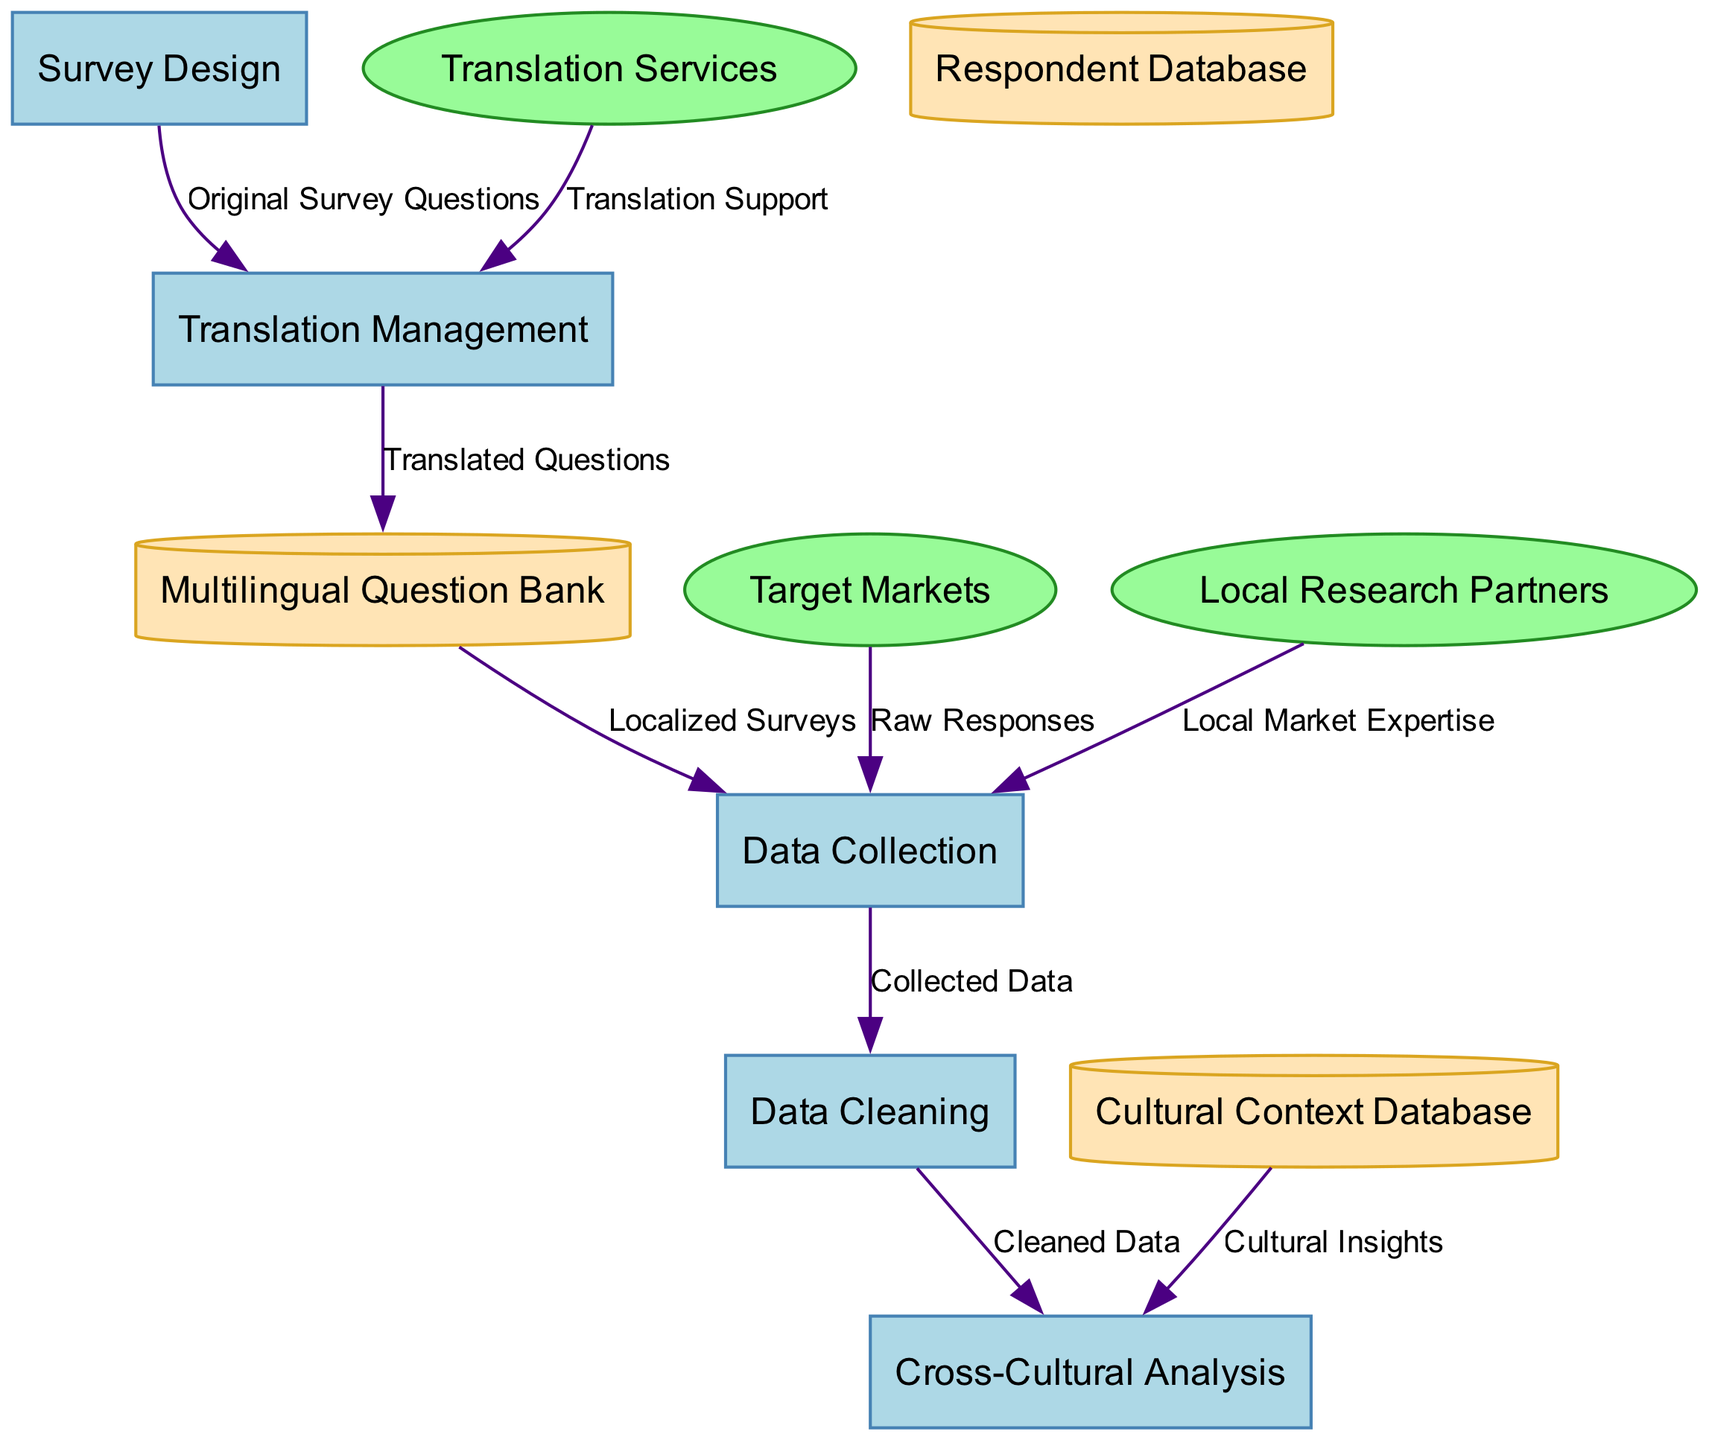What are the main processes in the diagram? The diagram lists five processes. These are: Survey Design, Translation Management, Data Collection, Data Cleaning, and Cross-Cultural Analysis.
Answer: Survey Design, Translation Management, Data Collection, Data Cleaning, Cross-Cultural Analysis Which node receives "Raw Responses"? "Data Collection" receives "Raw Responses" from "Target Markets." This is directly indicated by the data flow labeled as such in the diagram.
Answer: Data Collection How many external entities are present in the diagram? There are three external entities mentioned in the diagram: Target Markets, Translation Services, and Local Research Partners. The count of these entities provides the answer.
Answer: 3 What is the data flow labeled as "Localized Surveys"? The data flow labeled as "Localized Surveys" moves from "Multilingual Question Bank" to "Data Collection." This can be traced directly from the corresponding nodes in the diagram.
Answer: Localized Surveys What does the "Data Cleaning" process receive? "Data Cleaning" receives "Collected Data" from "Data Collection." The flow is explicitly illustrated in the diagram, showing this direct connection.
Answer: Collected Data Which external entity provides "Local Market Expertise"? "Local Research Partners" provides "Local Market Expertise" to "Data Collection." This relationship is clearly shown in the diagram through the specified data flow.
Answer: Local Research Partners How many data stores are depicted in the diagram? There are three data stores illustrated in the diagram: Multilingual Question Bank, Respondent Database, and Cultural Context Database. This total is derived from counting the stores listed within the diagram.
Answer: 3 What is transferred from "Translation Management" to "Multilingual Question Bank"? "Translation Management" transfers "Translated Questions" to "Multilingual Question Bank." This flow is clearly labeled in the diagram, indicating this specific transfer.
Answer: Translated Questions What type of diagram does this represent? The diagram specifically represents a Data Flow Diagram, as it illustrates the flow of information and data relationships between processes, external entities, and data stores in the context of multilingual survey creation.
Answer: Data Flow Diagram 